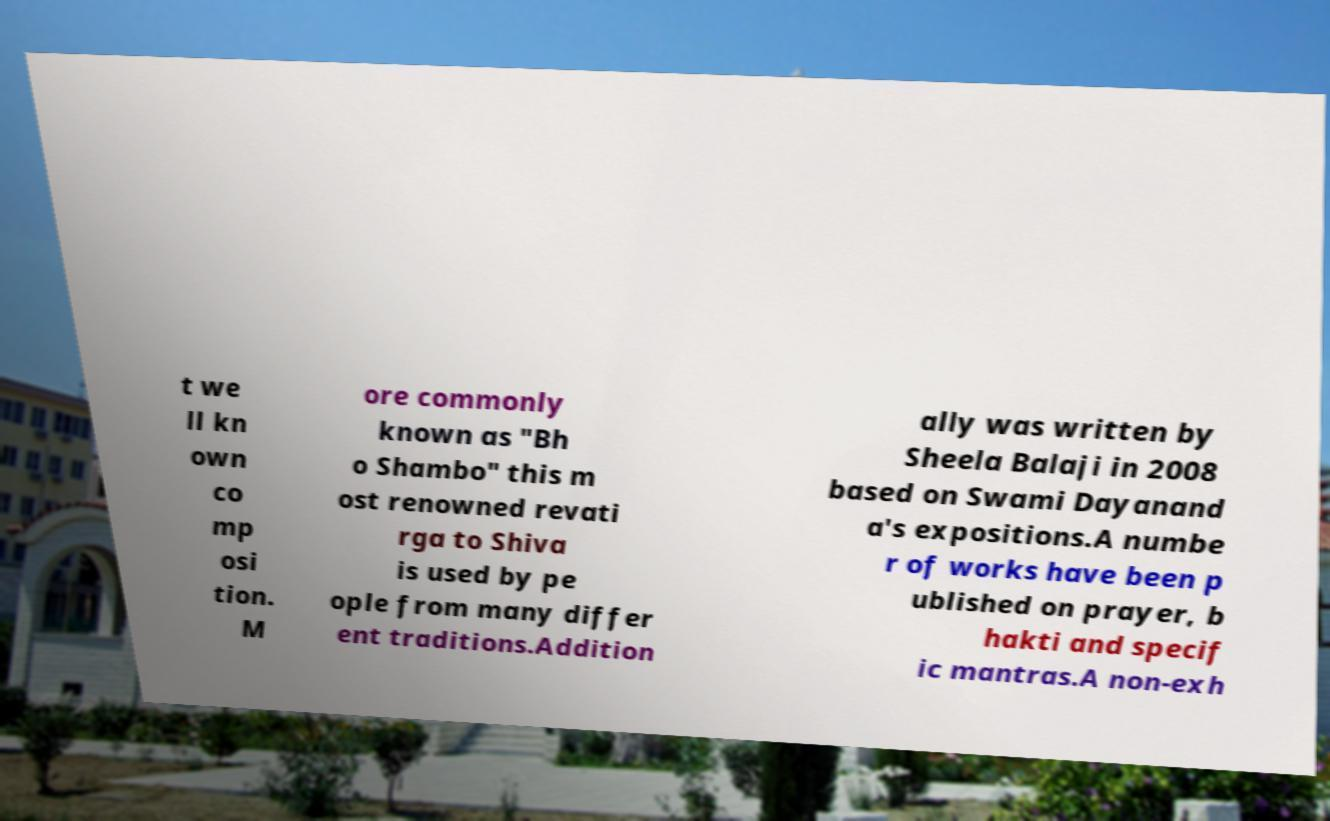I need the written content from this picture converted into text. Can you do that? t we ll kn own co mp osi tion. M ore commonly known as "Bh o Shambo" this m ost renowned revati rga to Shiva is used by pe ople from many differ ent traditions.Addition ally was written by Sheela Balaji in 2008 based on Swami Dayanand a's expositions.A numbe r of works have been p ublished on prayer, b hakti and specif ic mantras.A non-exh 